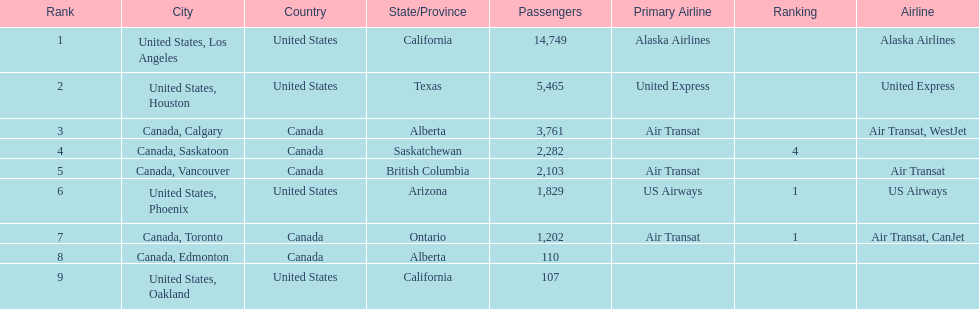Los angeles and what other city had about 19,000 passenger combined Canada, Calgary. 